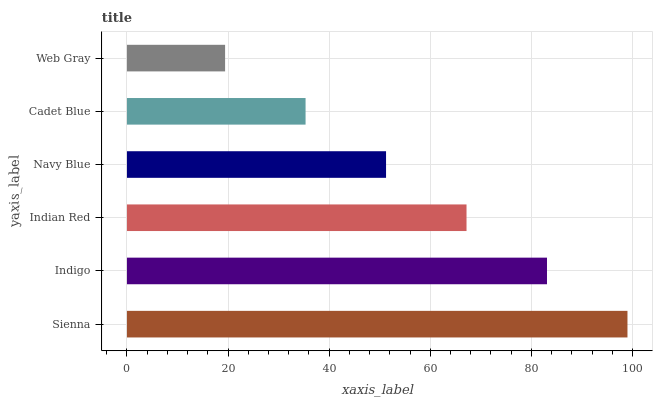Is Web Gray the minimum?
Answer yes or no. Yes. Is Sienna the maximum?
Answer yes or no. Yes. Is Indigo the minimum?
Answer yes or no. No. Is Indigo the maximum?
Answer yes or no. No. Is Sienna greater than Indigo?
Answer yes or no. Yes. Is Indigo less than Sienna?
Answer yes or no. Yes. Is Indigo greater than Sienna?
Answer yes or no. No. Is Sienna less than Indigo?
Answer yes or no. No. Is Indian Red the high median?
Answer yes or no. Yes. Is Navy Blue the low median?
Answer yes or no. Yes. Is Cadet Blue the high median?
Answer yes or no. No. Is Indigo the low median?
Answer yes or no. No. 